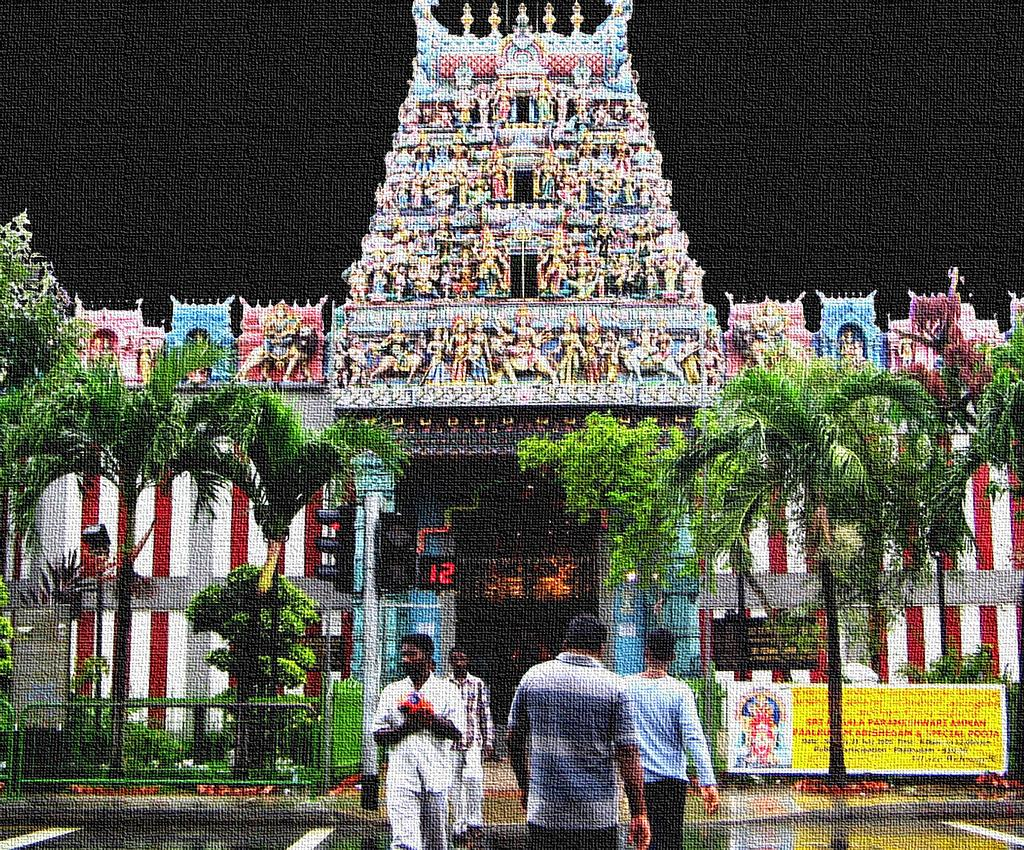Who or what can be seen in the image? There are people in the image. What type of natural elements are present in the image? There are trees in the image. What additional objects can be seen in the image? There is a banner, a board, a pole, and traffic signals in the image. What architectural features are visible in the background of the image? There is a temple arch and a wall in the background of the image. What type of pickle is hanging from the pole in the image? There is no pickle present in the image; it features people, trees, a banner, a board, a pole, traffic signals, a temple arch, and a wall. How many cherries are on the board in the image? There are no cherries present on the board in the image; it only features a board with unspecified content. What type of needle is being used by the people in the image? There is no needle present in the image; it features people, trees, a banner, a board, a pole, traffic signals, a temple arch, and a wall. 